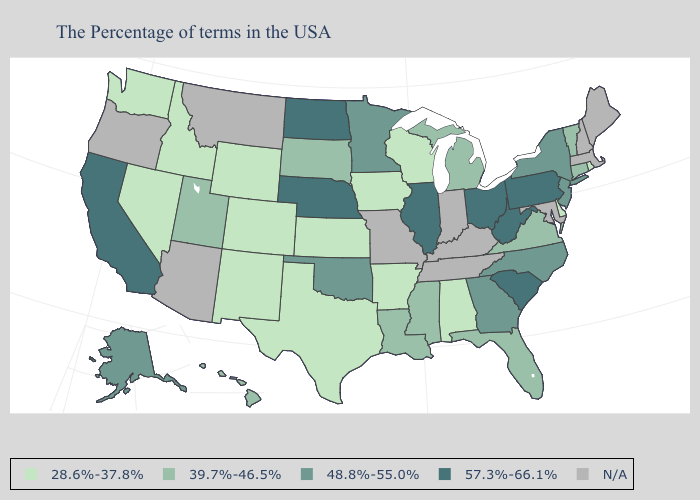What is the value of Kansas?
Give a very brief answer. 28.6%-37.8%. Does the first symbol in the legend represent the smallest category?
Short answer required. Yes. Name the states that have a value in the range 48.8%-55.0%?
Quick response, please. New York, New Jersey, North Carolina, Georgia, Minnesota, Oklahoma, Alaska. What is the value of Georgia?
Be succinct. 48.8%-55.0%. What is the lowest value in the MidWest?
Keep it brief. 28.6%-37.8%. Which states hav the highest value in the West?
Keep it brief. California. Does the first symbol in the legend represent the smallest category?
Concise answer only. Yes. What is the lowest value in the USA?
Be succinct. 28.6%-37.8%. Name the states that have a value in the range N/A?
Give a very brief answer. Maine, Massachusetts, New Hampshire, Maryland, Kentucky, Indiana, Tennessee, Missouri, Montana, Arizona, Oregon. What is the highest value in the USA?
Quick response, please. 57.3%-66.1%. Does California have the lowest value in the West?
Give a very brief answer. No. What is the value of Louisiana?
Keep it brief. 39.7%-46.5%. Name the states that have a value in the range N/A?
Be succinct. Maine, Massachusetts, New Hampshire, Maryland, Kentucky, Indiana, Tennessee, Missouri, Montana, Arizona, Oregon. Does the first symbol in the legend represent the smallest category?
Answer briefly. Yes. What is the value of Idaho?
Give a very brief answer. 28.6%-37.8%. 